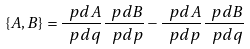<formula> <loc_0><loc_0><loc_500><loc_500>\{ A , B \} = \frac { \ p d A } { \ p d q } \frac { \ p d B } { \ p d p } - \frac { \ p d A } { \ p d p } \frac { \ p d B } { \ p d q }</formula> 